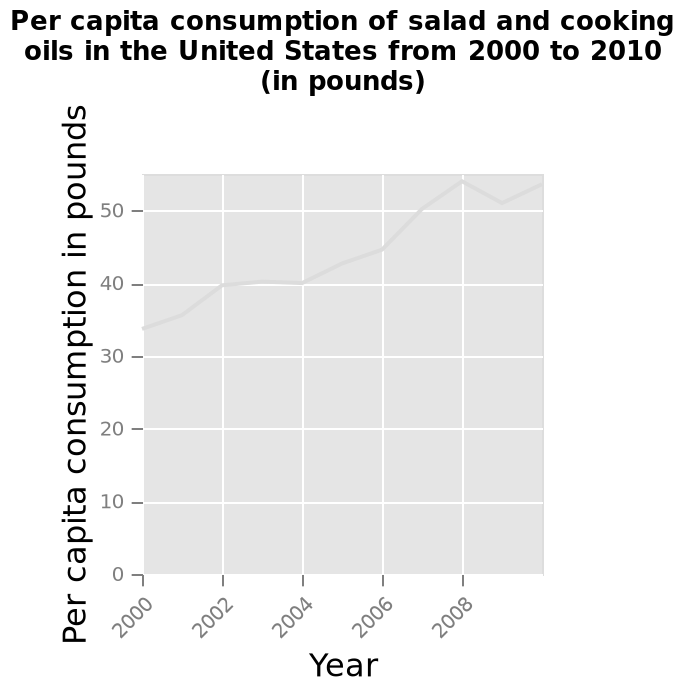<image>
please summary the statistics and relations of the chart The consumption of salad and cooking oils in the US has risen overall in the past 8 years. In the year 2000 the average annual consumption per person was of 34 pounds and in 2010 it has risen to 54 pounds per person. This trend has been erratic at times, with stable periods between 2002-2004 of 40 pounds per person and periods of rapid growth 45 to 55 pounds between the years 2006 and 2008. Were there any stable periods in the consumption of salad and cooking oils per person in the US between 2002 and 2004? Yes, between 2002 and 2004, the consumption per person remained stable at 40 pounds. Did the consumption of salad and cooking oils per person in the US experience rapid growth between 2006 and 2008? Yes, the consumption per person had rapid growth from 45 to 55 pounds between 2006 and 2008. 